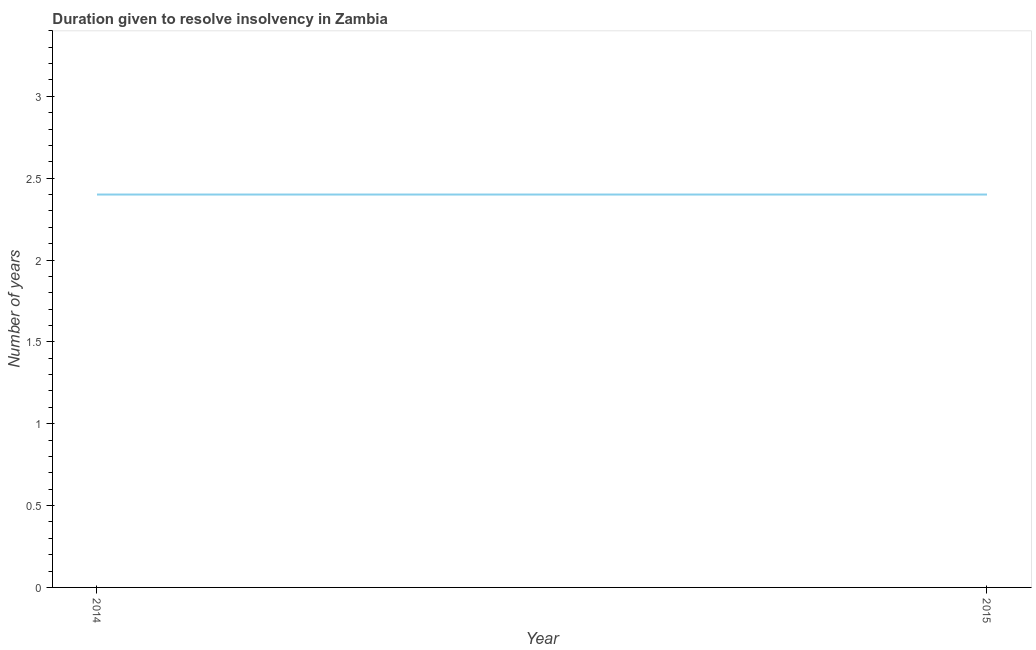What is the number of years to resolve insolvency in 2014?
Ensure brevity in your answer.  2.4. Across all years, what is the minimum number of years to resolve insolvency?
Your answer should be compact. 2.4. In which year was the number of years to resolve insolvency maximum?
Offer a terse response. 2014. What is the sum of the number of years to resolve insolvency?
Offer a terse response. 4.8. What is the average number of years to resolve insolvency per year?
Keep it short and to the point. 2.4. What is the ratio of the number of years to resolve insolvency in 2014 to that in 2015?
Give a very brief answer. 1. Is the number of years to resolve insolvency in 2014 less than that in 2015?
Ensure brevity in your answer.  No. Does the number of years to resolve insolvency monotonically increase over the years?
Keep it short and to the point. No. How many years are there in the graph?
Ensure brevity in your answer.  2. Are the values on the major ticks of Y-axis written in scientific E-notation?
Offer a terse response. No. Does the graph contain any zero values?
Provide a short and direct response. No. Does the graph contain grids?
Ensure brevity in your answer.  No. What is the title of the graph?
Provide a succinct answer. Duration given to resolve insolvency in Zambia. What is the label or title of the X-axis?
Make the answer very short. Year. What is the label or title of the Y-axis?
Ensure brevity in your answer.  Number of years. What is the Number of years of 2015?
Provide a short and direct response. 2.4. What is the difference between the Number of years in 2014 and 2015?
Make the answer very short. 0. 